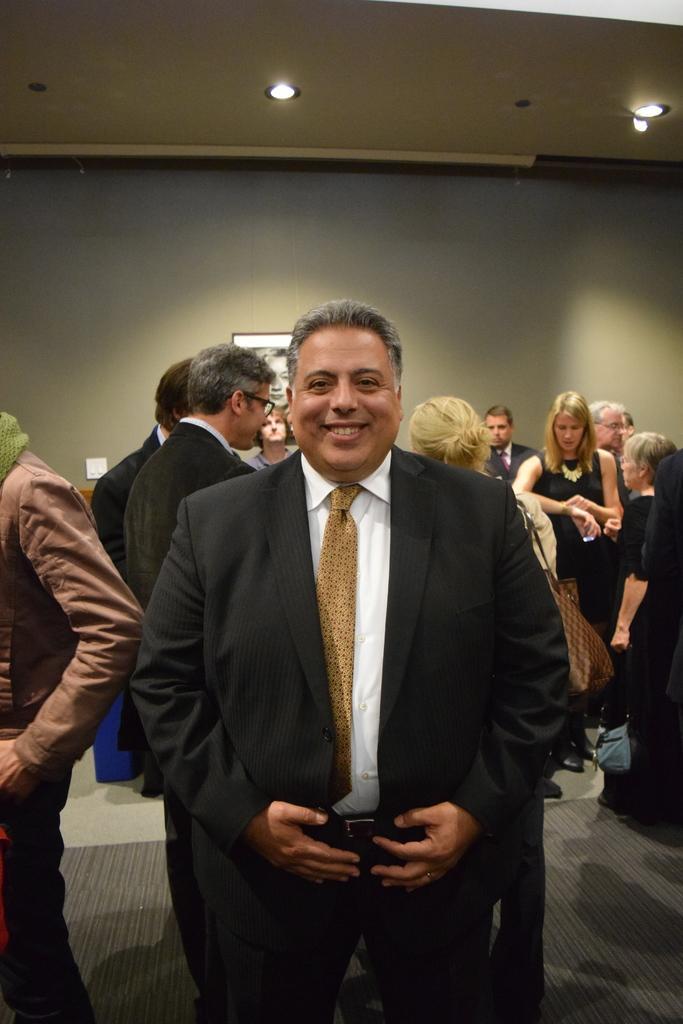Describe this image in one or two sentences. In the image in the center, we can see one person standing and he is smiling, which we can see on his face. In the background there is a wall, roof, photo frame, switchboard, lights and few people are standing. 